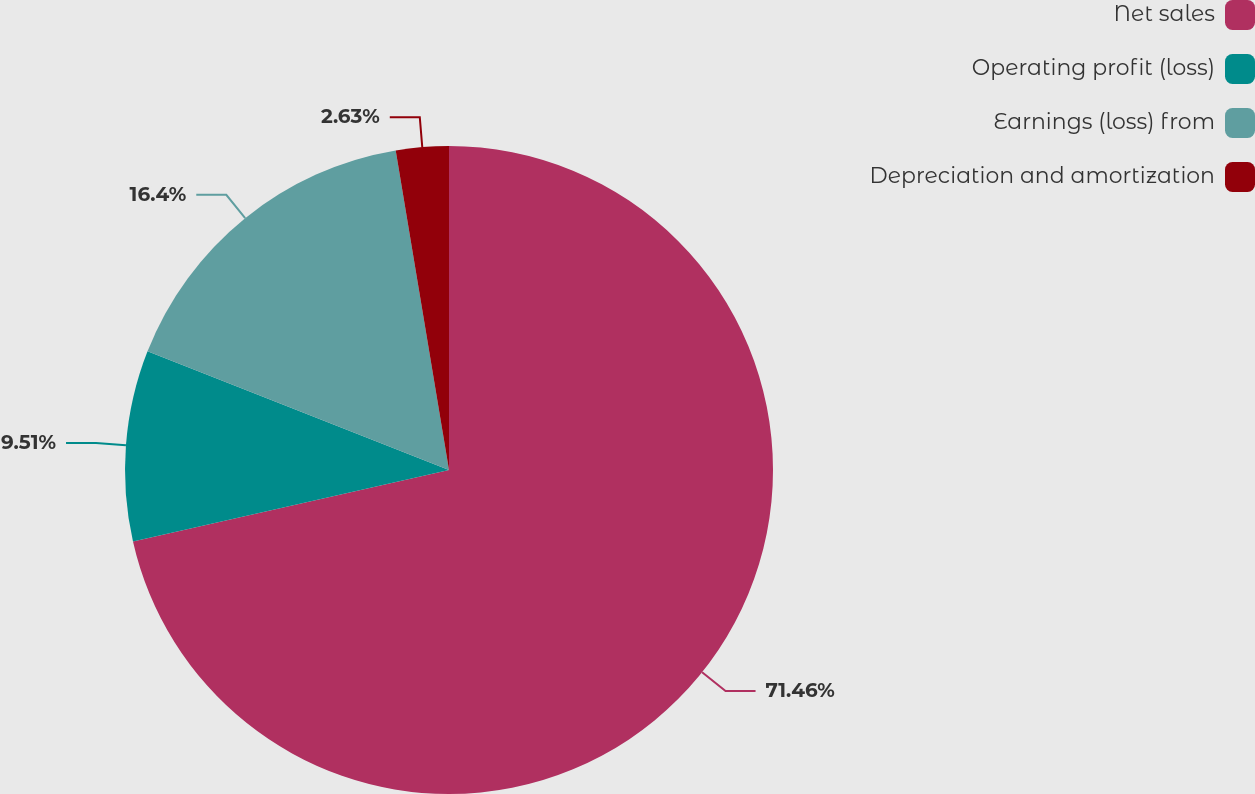Convert chart to OTSL. <chart><loc_0><loc_0><loc_500><loc_500><pie_chart><fcel>Net sales<fcel>Operating profit (loss)<fcel>Earnings (loss) from<fcel>Depreciation and amortization<nl><fcel>71.46%<fcel>9.51%<fcel>16.4%<fcel>2.63%<nl></chart> 